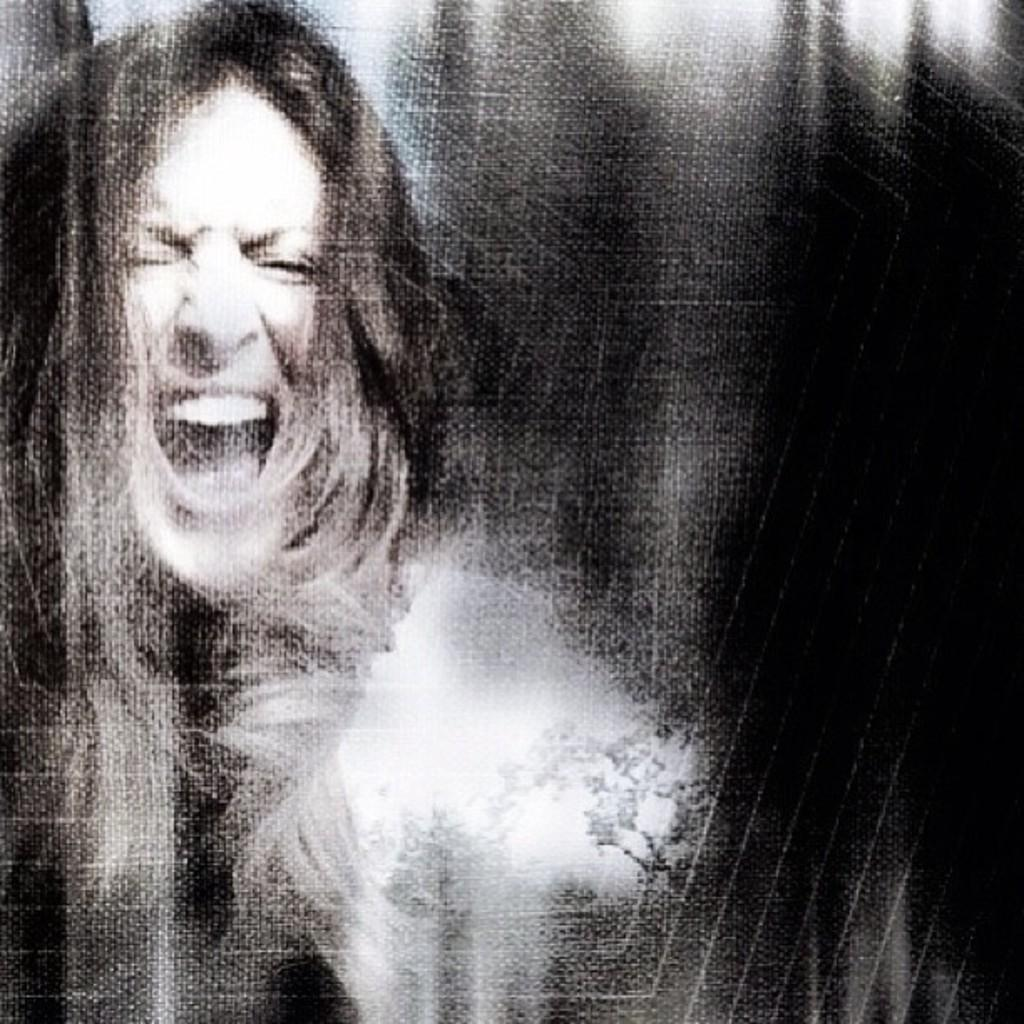What is the main subject in the image? There is a person in the image. Can you describe any other items that are visible in the image? There are other items in the image, but their specific details are not mentioned in the provided facts. What type of milk is being used to glue the person's ears in the image? There is no milk or glue present in the image, and the person's ears are not being glued. 